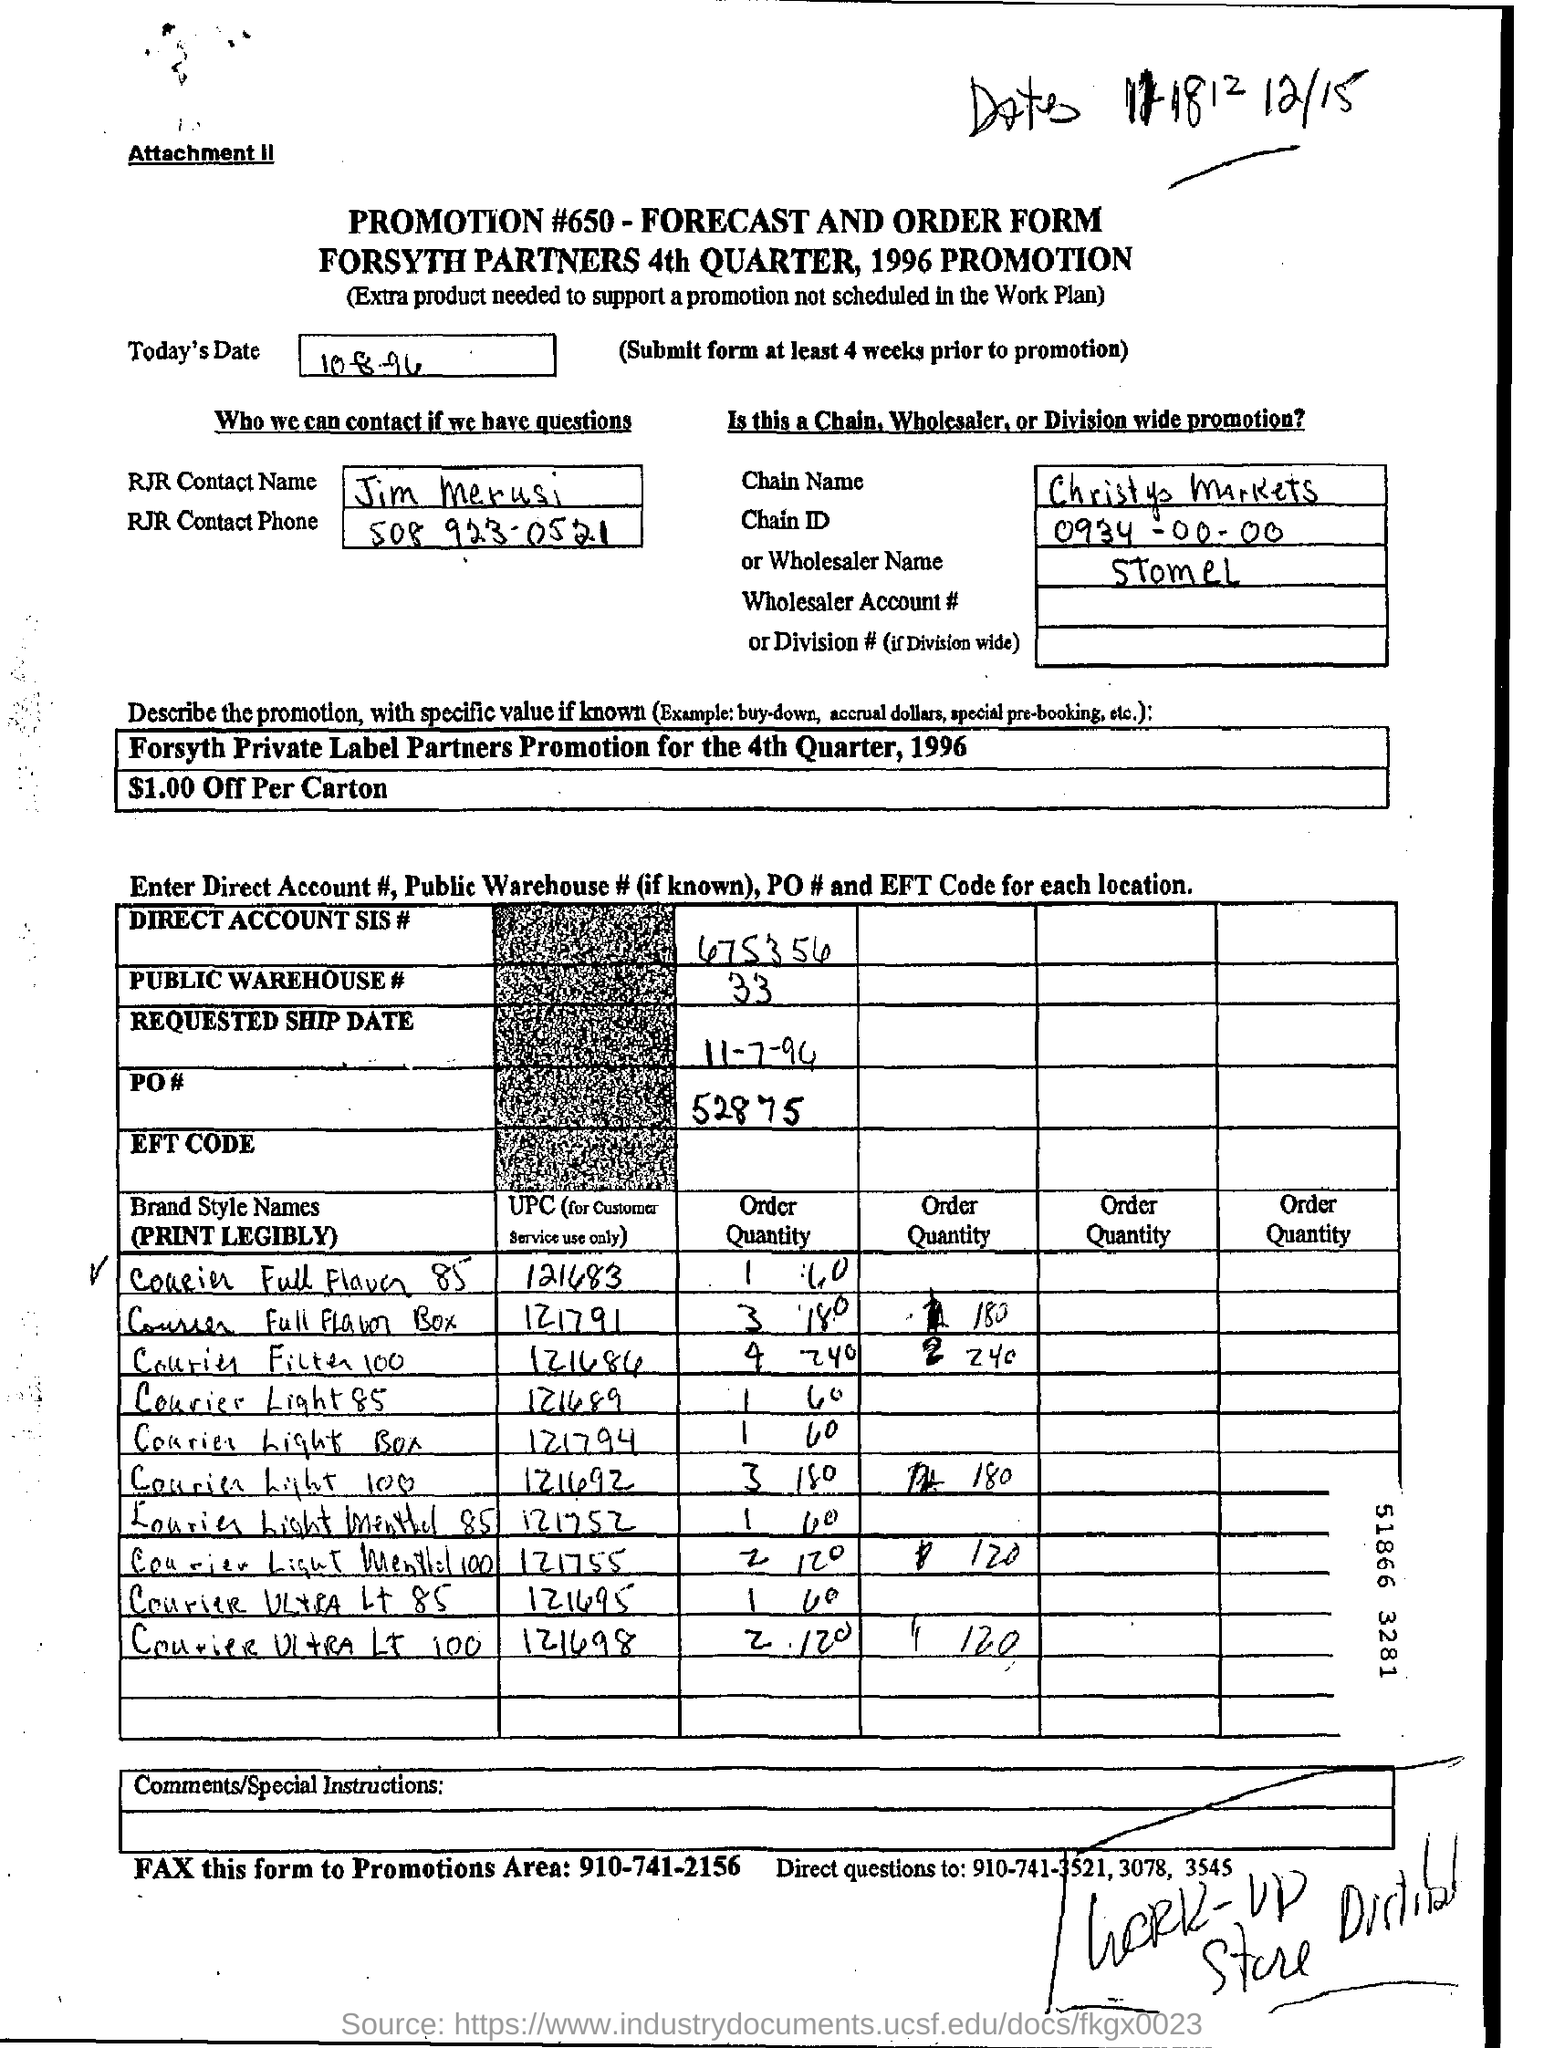Highlight a few significant elements in this photo. On what date is the document dated? 10-8-96. For inquiries, please contact Jim Merusi. 